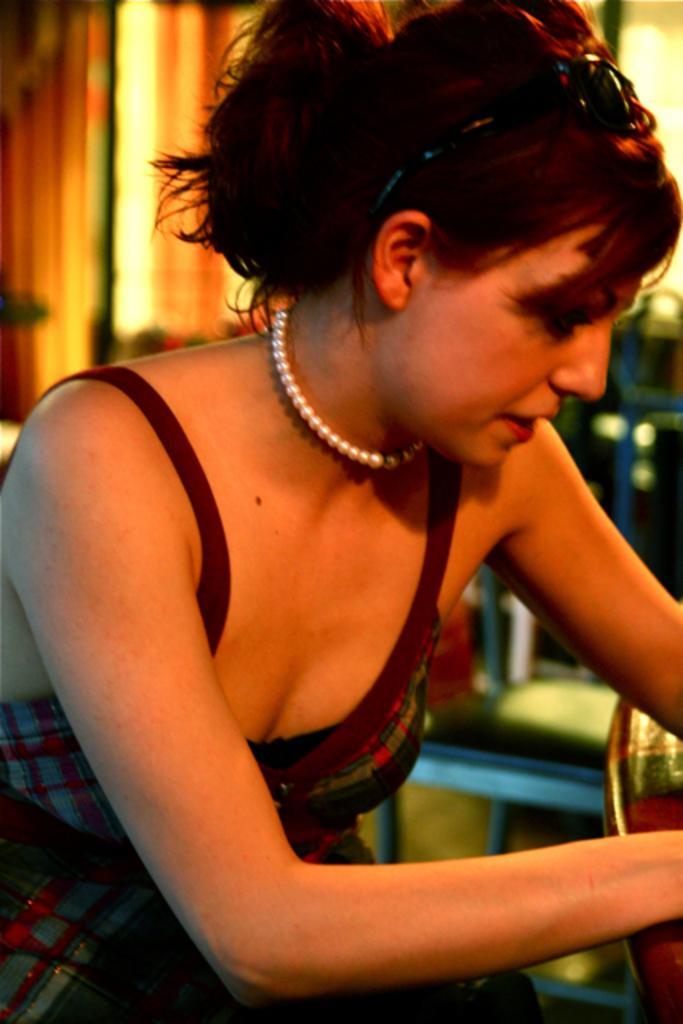Describe this image in one or two sentences. In this image there is a girl. The background is blurred. 